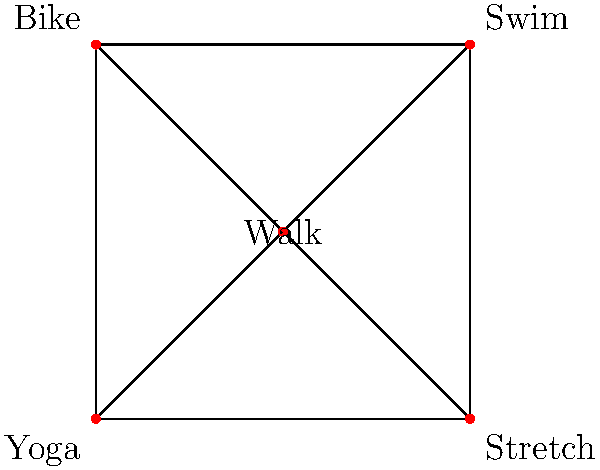In our cardiac rehabilitation program, we've mapped out different exercise routines as nodes in a graph. Each edge represents a possible transition between exercises. If we remove one node from this graph, what is the maximum number of connected components that could result? Let's approach this step-by-step:

1) First, we need to understand what the graph represents:
   - There are 5 nodes: Walk, Swim, Bike, Yoga, and Stretch
   - Each node is connected to at least two other nodes

2) To find the maximum number of connected components after removing one node, we need to identify the node that, when removed, would break the graph into the most pieces.

3) Let's consider each node:
   - Walk: Connected to all other nodes. Removing it would leave the other 4 nodes still connected in a cycle. Result: 1 component
   - Swim: Connected to Walk, Bike, and Stretch. Removing it would not disconnect the graph. Result: 1 component
   - Bike: Connected to Walk, Swim, and Yoga. Removing it would not disconnect the graph. Result: 1 component
   - Yoga: Connected to Walk, Bike, and Stretch. Removing it would not disconnect the graph. Result: 1 component
   - Stretch: Connected to Walk, Swim, and Yoga. Removing it would not disconnect the graph. Result: 1 component

4) We can see that no matter which node we remove, the graph remains connected as a single component.

5) Therefore, the maximum number of connected components after removing any single node is 1.

This reflects the robustness of our exercise routine network, as no single exercise is a critical point of failure for the entire program.
Answer: 1 